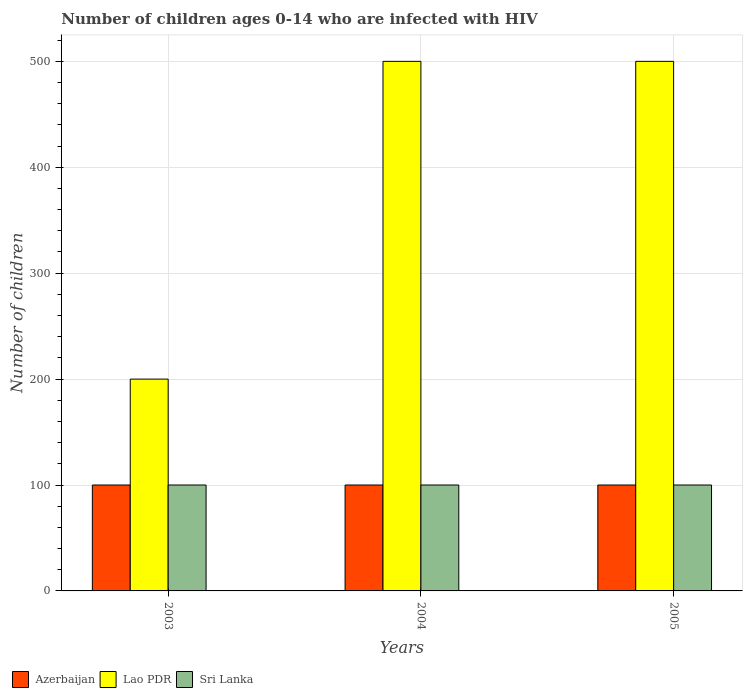How many different coloured bars are there?
Make the answer very short. 3. How many groups of bars are there?
Your response must be concise. 3. What is the number of HIV infected children in Azerbaijan in 2004?
Provide a short and direct response. 100. Across all years, what is the maximum number of HIV infected children in Azerbaijan?
Ensure brevity in your answer.  100. Across all years, what is the minimum number of HIV infected children in Lao PDR?
Your answer should be compact. 200. In which year was the number of HIV infected children in Azerbaijan maximum?
Offer a terse response. 2003. What is the total number of HIV infected children in Sri Lanka in the graph?
Ensure brevity in your answer.  300. What is the difference between the number of HIV infected children in Lao PDR in 2005 and the number of HIV infected children in Azerbaijan in 2004?
Keep it short and to the point. 400. What is the average number of HIV infected children in Sri Lanka per year?
Keep it short and to the point. 100. In the year 2005, what is the difference between the number of HIV infected children in Sri Lanka and number of HIV infected children in Azerbaijan?
Your answer should be compact. 0. In how many years, is the number of HIV infected children in Sri Lanka greater than 240?
Your answer should be compact. 0. What is the ratio of the number of HIV infected children in Lao PDR in 2003 to that in 2005?
Your answer should be very brief. 0.4. Is the number of HIV infected children in Azerbaijan in 2004 less than that in 2005?
Your response must be concise. No. Is the difference between the number of HIV infected children in Sri Lanka in 2003 and 2005 greater than the difference between the number of HIV infected children in Azerbaijan in 2003 and 2005?
Your response must be concise. No. What is the difference between the highest and the second highest number of HIV infected children in Lao PDR?
Your response must be concise. 0. What is the difference between the highest and the lowest number of HIV infected children in Lao PDR?
Make the answer very short. 300. In how many years, is the number of HIV infected children in Lao PDR greater than the average number of HIV infected children in Lao PDR taken over all years?
Your answer should be very brief. 2. What does the 1st bar from the left in 2005 represents?
Offer a terse response. Azerbaijan. What does the 1st bar from the right in 2004 represents?
Offer a terse response. Sri Lanka. How many bars are there?
Your answer should be very brief. 9. Are all the bars in the graph horizontal?
Your answer should be very brief. No. How many years are there in the graph?
Provide a short and direct response. 3. What is the difference between two consecutive major ticks on the Y-axis?
Ensure brevity in your answer.  100. Does the graph contain grids?
Your response must be concise. Yes. Where does the legend appear in the graph?
Your answer should be compact. Bottom left. How many legend labels are there?
Give a very brief answer. 3. How are the legend labels stacked?
Your answer should be compact. Horizontal. What is the title of the graph?
Keep it short and to the point. Number of children ages 0-14 who are infected with HIV. Does "Guam" appear as one of the legend labels in the graph?
Give a very brief answer. No. What is the label or title of the X-axis?
Offer a very short reply. Years. What is the label or title of the Y-axis?
Provide a short and direct response. Number of children. What is the Number of children of Azerbaijan in 2003?
Provide a succinct answer. 100. What is the Number of children in Azerbaijan in 2004?
Give a very brief answer. 100. What is the Number of children in Azerbaijan in 2005?
Provide a short and direct response. 100. Across all years, what is the maximum Number of children in Azerbaijan?
Ensure brevity in your answer.  100. Across all years, what is the minimum Number of children of Azerbaijan?
Offer a very short reply. 100. Across all years, what is the minimum Number of children in Sri Lanka?
Give a very brief answer. 100. What is the total Number of children of Azerbaijan in the graph?
Give a very brief answer. 300. What is the total Number of children of Lao PDR in the graph?
Your answer should be compact. 1200. What is the total Number of children in Sri Lanka in the graph?
Your answer should be compact. 300. What is the difference between the Number of children of Lao PDR in 2003 and that in 2004?
Provide a short and direct response. -300. What is the difference between the Number of children of Sri Lanka in 2003 and that in 2004?
Offer a terse response. 0. What is the difference between the Number of children in Lao PDR in 2003 and that in 2005?
Give a very brief answer. -300. What is the difference between the Number of children in Sri Lanka in 2003 and that in 2005?
Provide a short and direct response. 0. What is the difference between the Number of children of Azerbaijan in 2004 and that in 2005?
Your response must be concise. 0. What is the difference between the Number of children of Lao PDR in 2004 and that in 2005?
Provide a short and direct response. 0. What is the difference between the Number of children of Sri Lanka in 2004 and that in 2005?
Offer a terse response. 0. What is the difference between the Number of children of Azerbaijan in 2003 and the Number of children of Lao PDR in 2004?
Provide a short and direct response. -400. What is the difference between the Number of children of Lao PDR in 2003 and the Number of children of Sri Lanka in 2004?
Your answer should be compact. 100. What is the difference between the Number of children of Azerbaijan in 2003 and the Number of children of Lao PDR in 2005?
Offer a very short reply. -400. What is the difference between the Number of children of Azerbaijan in 2003 and the Number of children of Sri Lanka in 2005?
Offer a very short reply. 0. What is the difference between the Number of children in Azerbaijan in 2004 and the Number of children in Lao PDR in 2005?
Offer a very short reply. -400. What is the difference between the Number of children in Lao PDR in 2004 and the Number of children in Sri Lanka in 2005?
Make the answer very short. 400. What is the average Number of children of Sri Lanka per year?
Make the answer very short. 100. In the year 2003, what is the difference between the Number of children in Azerbaijan and Number of children in Lao PDR?
Your response must be concise. -100. In the year 2003, what is the difference between the Number of children of Azerbaijan and Number of children of Sri Lanka?
Provide a succinct answer. 0. In the year 2004, what is the difference between the Number of children in Azerbaijan and Number of children in Lao PDR?
Offer a very short reply. -400. In the year 2005, what is the difference between the Number of children in Azerbaijan and Number of children in Lao PDR?
Give a very brief answer. -400. In the year 2005, what is the difference between the Number of children in Lao PDR and Number of children in Sri Lanka?
Make the answer very short. 400. What is the ratio of the Number of children of Azerbaijan in 2003 to that in 2004?
Keep it short and to the point. 1. What is the ratio of the Number of children of Sri Lanka in 2003 to that in 2004?
Your response must be concise. 1. What is the ratio of the Number of children of Azerbaijan in 2003 to that in 2005?
Your answer should be compact. 1. What is the ratio of the Number of children of Lao PDR in 2003 to that in 2005?
Make the answer very short. 0.4. What is the ratio of the Number of children of Sri Lanka in 2003 to that in 2005?
Keep it short and to the point. 1. What is the ratio of the Number of children in Sri Lanka in 2004 to that in 2005?
Provide a short and direct response. 1. What is the difference between the highest and the second highest Number of children in Lao PDR?
Ensure brevity in your answer.  0. What is the difference between the highest and the lowest Number of children in Lao PDR?
Make the answer very short. 300. What is the difference between the highest and the lowest Number of children in Sri Lanka?
Provide a short and direct response. 0. 